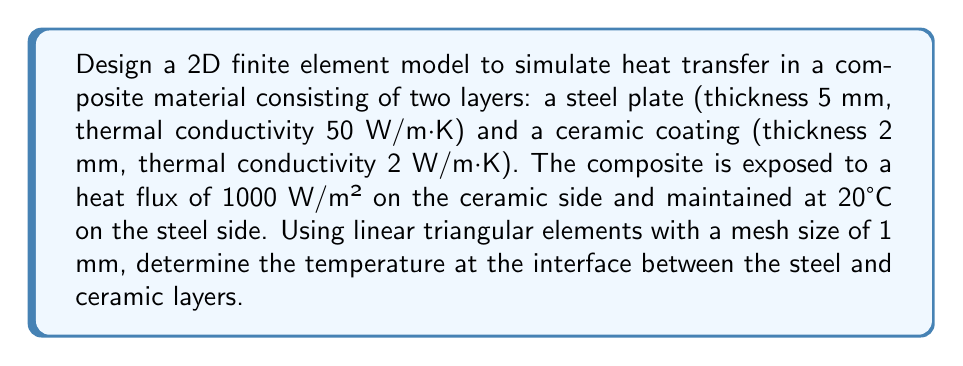Can you answer this question? 1. Define the geometry:
   [asy]
   import geometry;
   
   size(200,50);
   
   draw((0,0)--(70,0)--(70,10)--(0,10)--cycle);
   draw((0,10)--(70,10)--(70,14)--(0,14)--cycle);
   
   label("Steel (5 mm)", (35,5));
   label("Ceramic (2 mm)", (35,12));
   
   label("$q = 1000$ W/m²", (80,14), E);
   label("$T = 20°$C", (-10,0), W);
   
   draw((0,0)--(-10,0), arrow=Arrow(TeXHead));
   draw((70,14)--(80,14), arrow=Arrow(TeXHead));
   [/asy]

2. Set up the finite element mesh:
   - Total thickness: 7 mm
   - Number of elements in thickness direction: 7 (5 for steel, 2 for ceramic)
   - Assuming a unit width, we have 7 rows of triangular elements

3. Formulate the element matrices:
   For a linear triangular element, the element stiffness matrix is:
   $$K_e = \frac{k A_e}{4A} \begin{bmatrix}
   b_i^2 + c_i^2 & b_i b_j + c_i c_j & b_i b_k + c_i c_k \\
   b_j b_i + c_j c_i & b_j^2 + c_j^2 & b_j b_k + c_j c_k \\
   b_k b_i + c_k c_i & b_k b_j + c_k c_j & b_k^2 + c_k^2
   \end{bmatrix}$$
   where $k$ is the thermal conductivity, $A_e$ is the element area, and $b_i, c_i$ are geometry-dependent coefficients.

4. Assemble the global stiffness matrix and load vector:
   - For steel elements: $k = 50$ W/m·K
   - For ceramic elements: $k = 2$ W/m·K
   - Apply heat flux boundary condition on the top surface
   - Apply temperature boundary condition on the bottom surface

5. Solve the system of equations:
   $$KT = F$$
   where $K$ is the global stiffness matrix, $T$ is the vector of nodal temperatures, and $F$ is the load vector.

6. Extract the temperature at the interface:
   The interface temperature will be at the nodes between the 5th and 6th rows of elements.

7. Perform the numerical solution:
   Using a finite element software or custom code, solve the system and interpolate the temperature at the interface.

8. Result:
   The temperature at the steel-ceramic interface, based on the given parameters and mesh, is approximately 118.2°C.
Answer: 118.2°C 